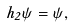Convert formula to latex. <formula><loc_0><loc_0><loc_500><loc_500>h _ { 2 } \psi = \psi ,</formula> 